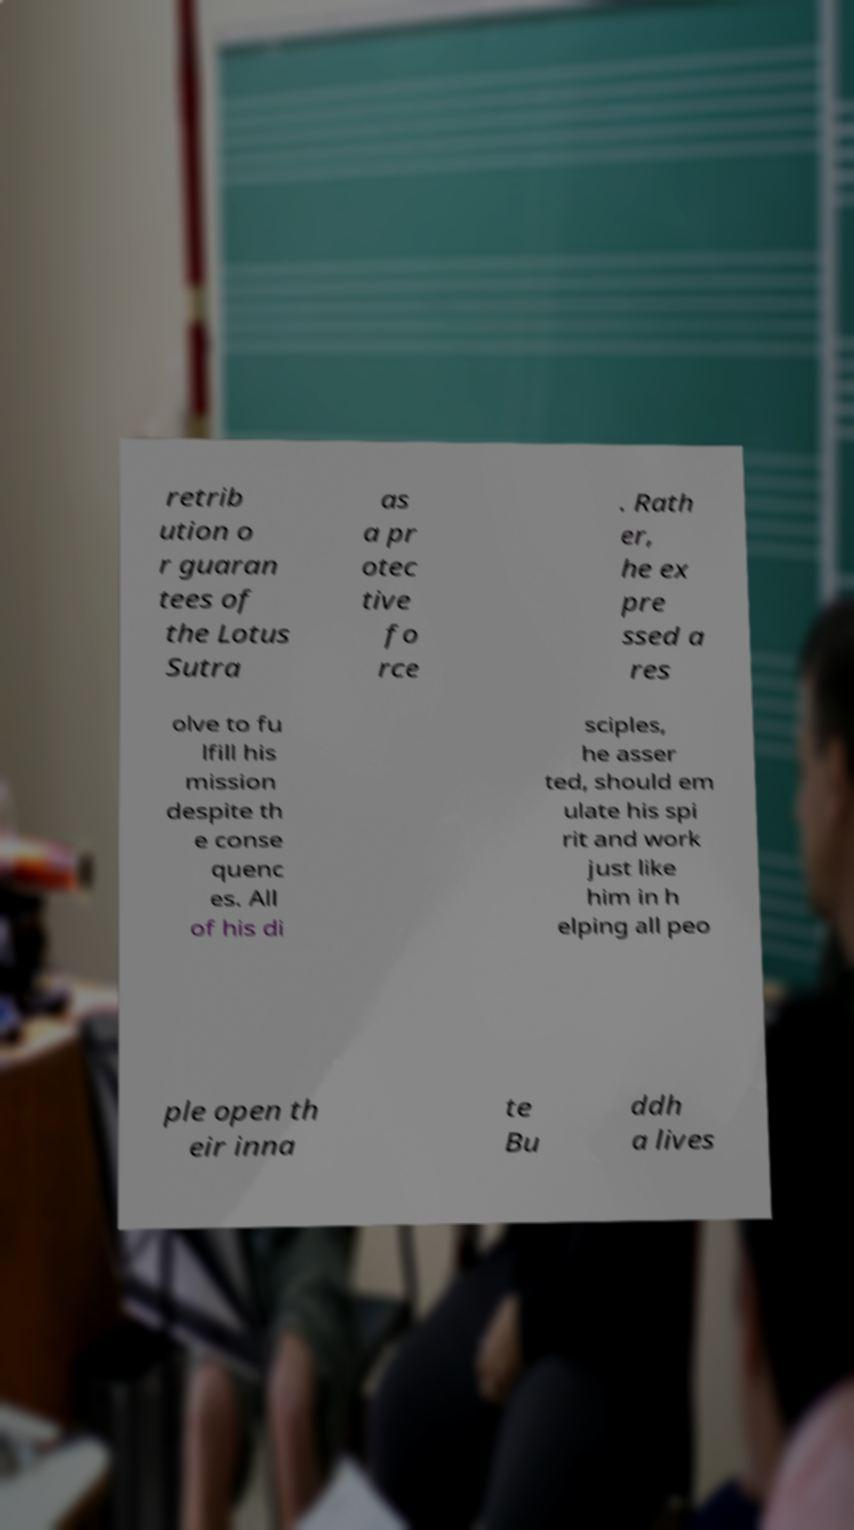Please read and relay the text visible in this image. What does it say? retrib ution o r guaran tees of the Lotus Sutra as a pr otec tive fo rce . Rath er, he ex pre ssed a res olve to fu lfill his mission despite th e conse quenc es. All of his di sciples, he asser ted, should em ulate his spi rit and work just like him in h elping all peo ple open th eir inna te Bu ddh a lives 